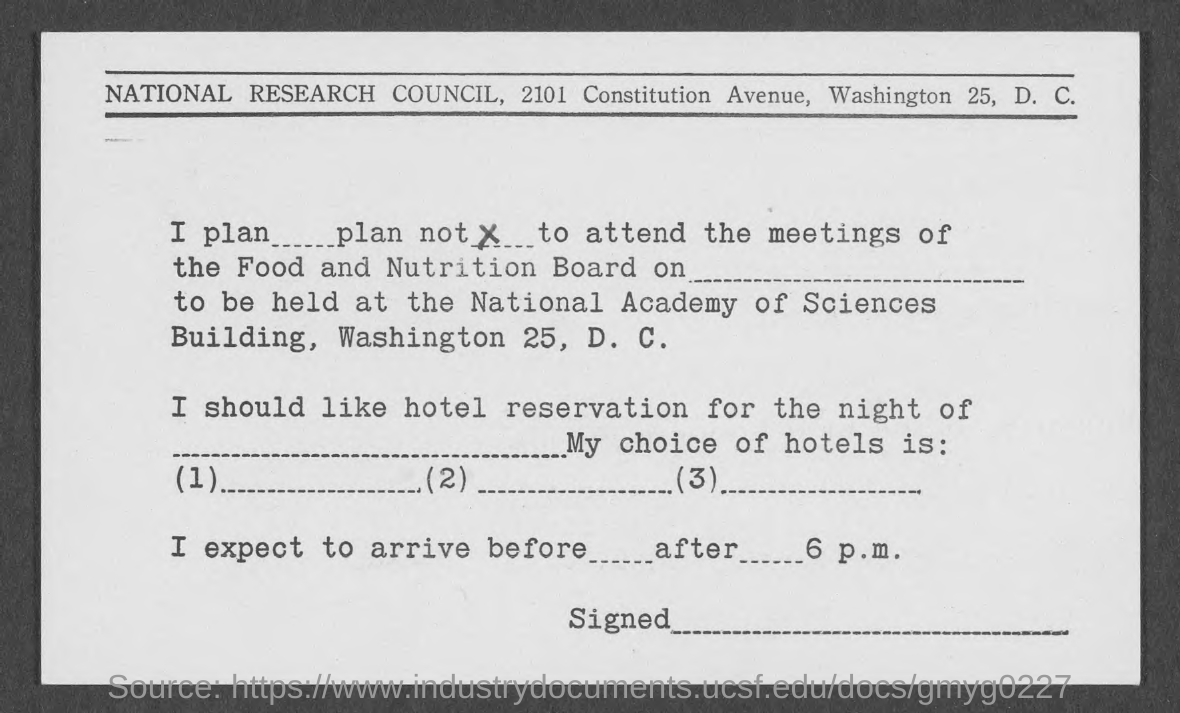Indicate a few pertinent items in this graphic. The National Research Council is mentioned in the header of the document. 